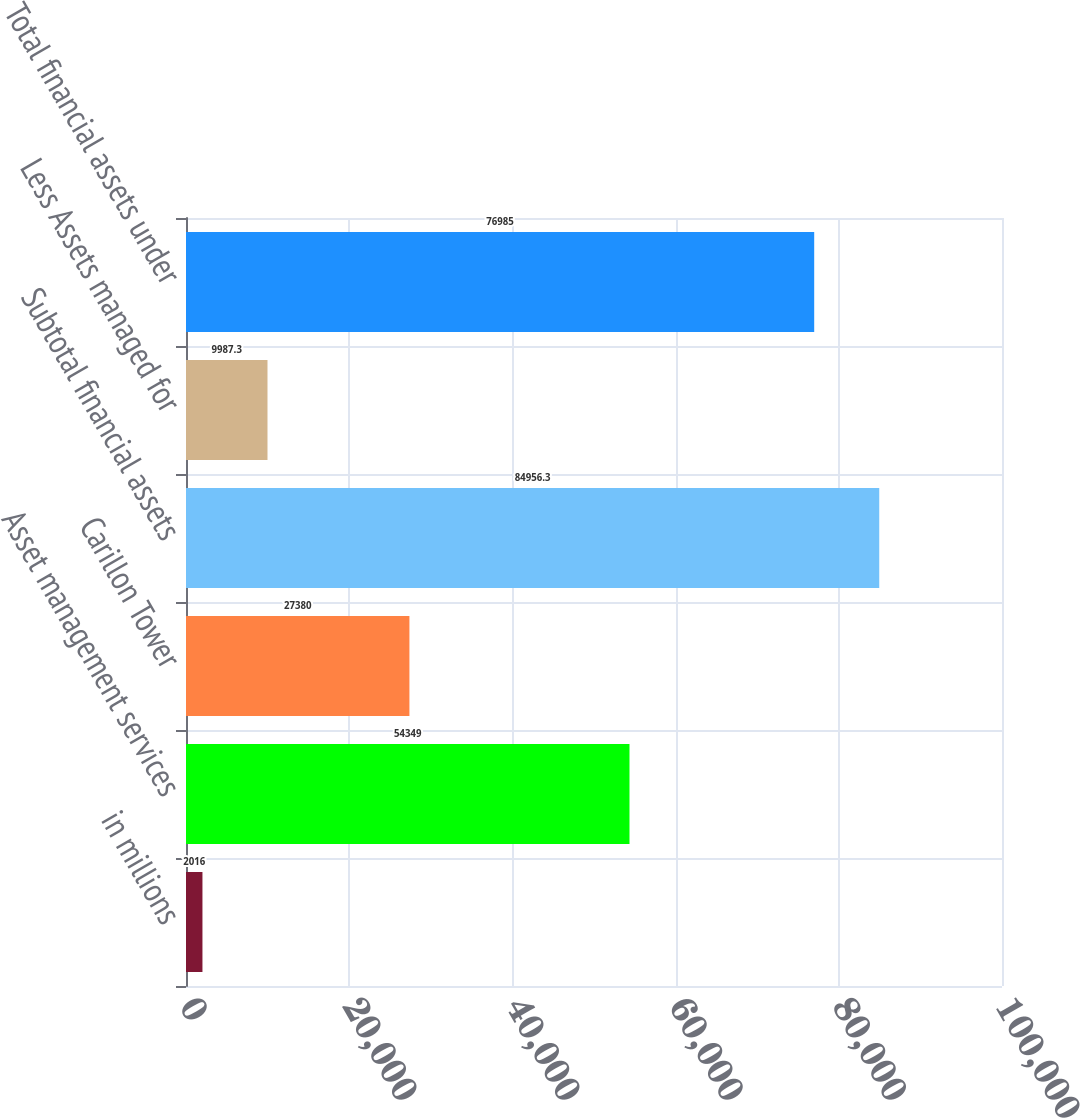Convert chart to OTSL. <chart><loc_0><loc_0><loc_500><loc_500><bar_chart><fcel>in millions<fcel>Asset management services<fcel>Carillon Tower<fcel>Subtotal financial assets<fcel>Less Assets managed for<fcel>Total financial assets under<nl><fcel>2016<fcel>54349<fcel>27380<fcel>84956.3<fcel>9987.3<fcel>76985<nl></chart> 